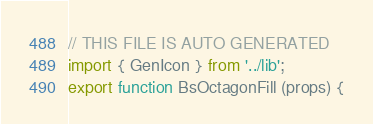<code> <loc_0><loc_0><loc_500><loc_500><_JavaScript_>// THIS FILE IS AUTO GENERATED
import { GenIcon } from '../lib';
export function BsOctagonFill (props) {</code> 